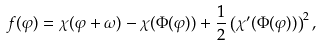<formula> <loc_0><loc_0><loc_500><loc_500>f ( \varphi ) = \chi ( \varphi + \omega ) - \chi ( \Phi ( \varphi ) ) + \frac { 1 } { 2 } \left ( \chi ^ { \prime } ( \Phi ( \varphi ) ) \right ) ^ { 2 } ,</formula> 